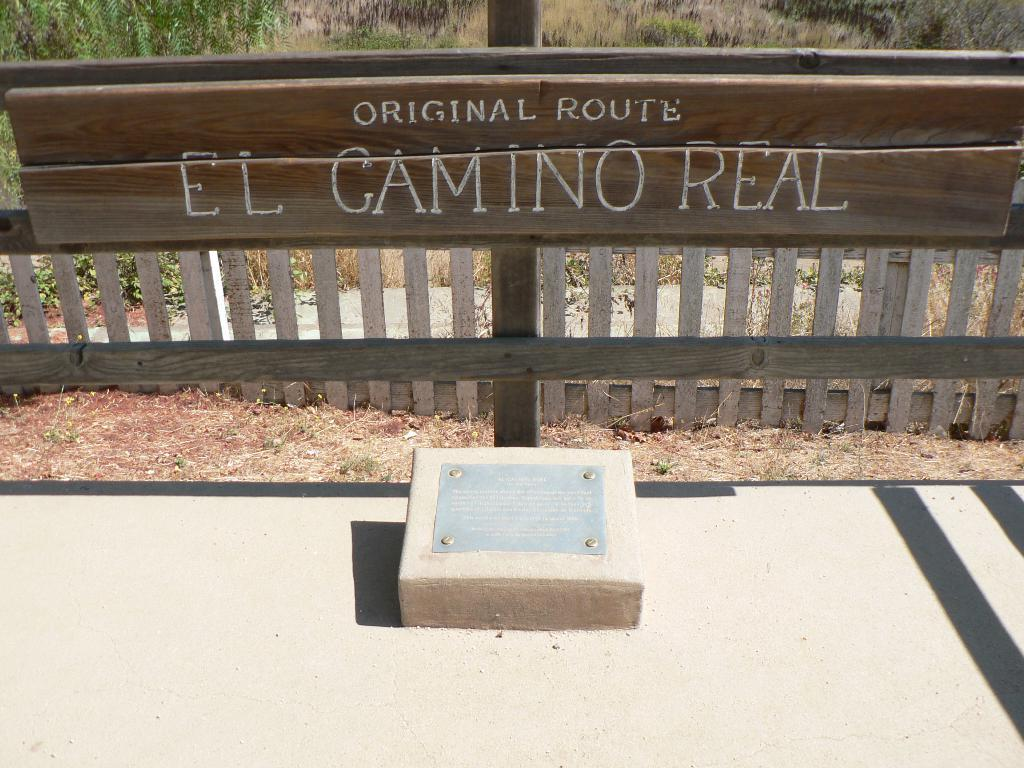What is the main feature in the center of the image? There is text on a board in the center of the image. What can be seen in the image besides the text on the board? There is a fence, trees in the background, a stone at the bottom, and ground visible in the image. What type of music can be heard coming from the tree in the image? There is no tree with music in the image; the only trees are in the background. 